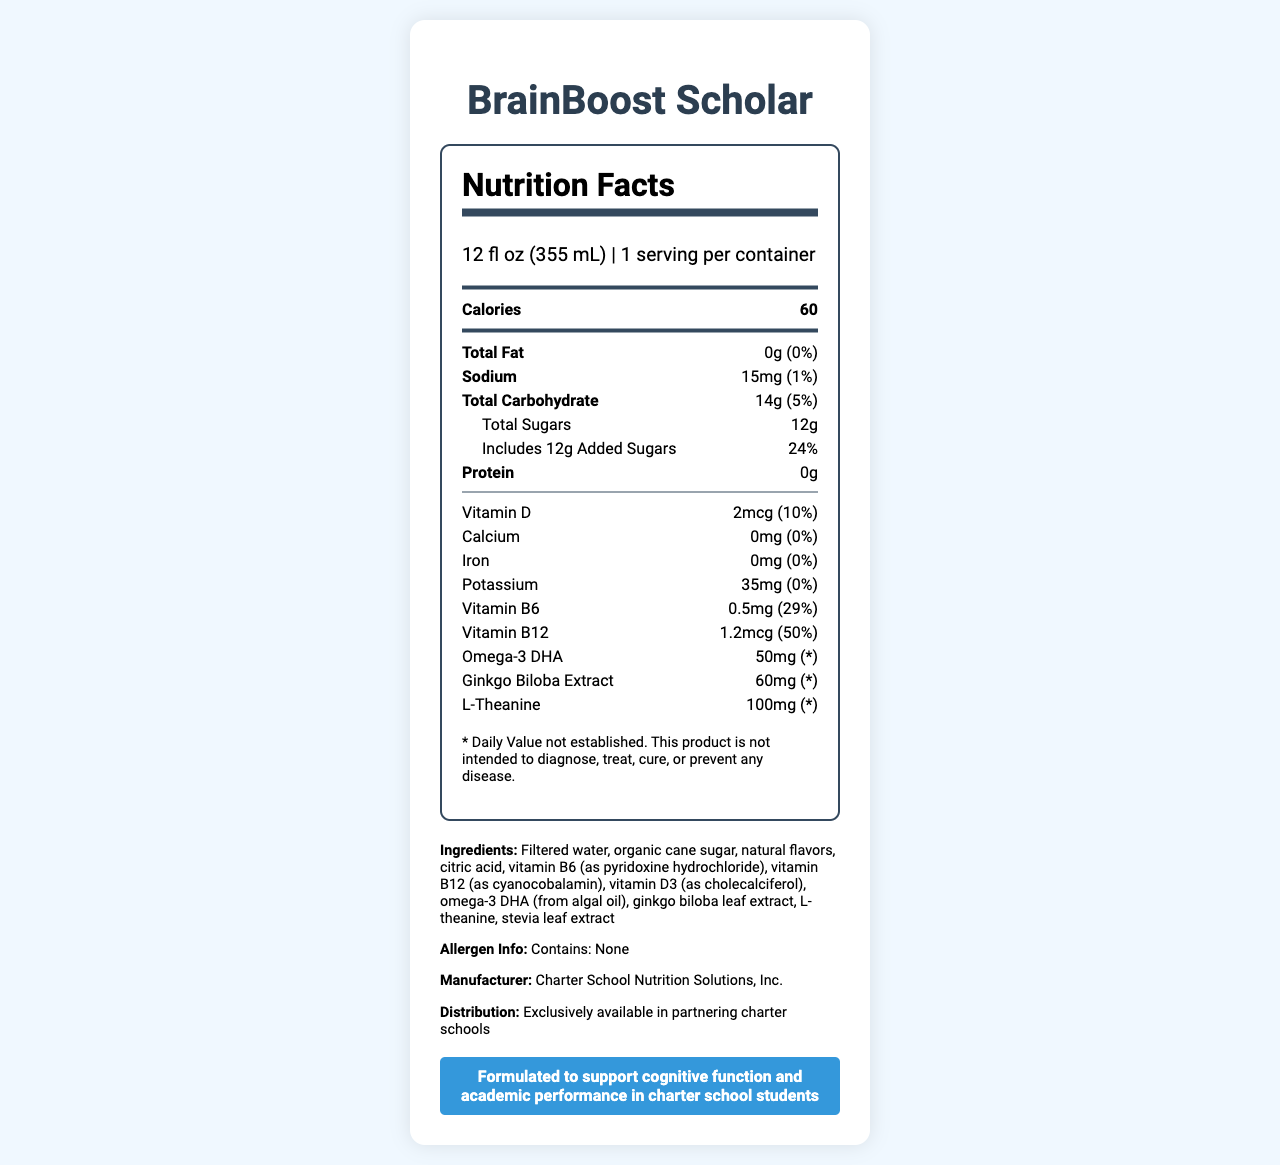which product is mentioned in the document? The product name "BrainBoost Scholar" is prominently displayed at the top of the nutrition facts label.
Answer: BrainBoost Scholar what is the serving size? The serving size is listed near the top of the nutrition label as "12 fl oz (355 mL)."
Answer: 12 fl oz (355 mL) how many calories are in one serving? The calories per serving are shown as "Calories 60" in a bold font.
Answer: 60 what is the amount of sodium per serving? The sodium content per serving is listed as 15mg in the nutrition facts.
Answer: 15mg how much protein does the beverage contain? The protein content is highlighted with the amount "0g" indicated next to it in the nutrition facts.
Answer: 0g how many grams of total sugars are in the beverage? The total sugars are marked as "Total Sugars 12g" in the nutrition facts section.
Answer: 12g what type of vitamins are primarily highlighted in this beverage? The vitamins prominently listed include Vitamin D (2mcg, 10% DV), Vitamin B6 (0.5mg, 29% DV), and Vitamin B12 (1.2mcg, 50% DV).
Answer: Vitamin D, Vitamin B6, and Vitamin B12 which nutrient has the highest Daily Value percentage? A. Sodium B. Vitamin B6 C. Vitamin B12 D. Omega-3 DHA Vitamin B12 has the highest Daily Value percentage at 50%.
Answer: C. Vitamin B12 how many grams of added sugars are in this beverage? A. 0g B. 5g C. 12g D. 14g The added sugars content is shown explicitly as "Includes 12g Added Sugars."
Answer: C. 12g is the product exclusively available in partnering charter schools? The distribution section mentions that the product is "Exclusively available in partnering charter schools."
Answer: Yes does the beverage contain any allergens? The allergen information specified "Contains: None," meaning there are no allergens present in the beverage.
Answer: No what are the main claims made about the beverage’s benefits? The marketing claim mentions that the beverage is aimed at supporting cognitive function and academic performance in charter school students.
Answer: Formulated to support cognitive function and academic performance in charter school students what company manufactures BrainBoost Scholar? The manufacturer is listed as "Charter School Nutrition Solutions, Inc." in the ingredients section.
Answer: Charter School Nutrition Solutions, Inc. does the document provide enough information to determine the exact retail price of the beverage? The document does not include any pricing details or any information related to the retail price of the beverage.
Answer: Not enough information what is the main purpose of the document? The document thoroughly details the nutrition facts, ingredients, claims, and distribution specifics for the BrainBoost Scholar beverage, emphasizing its benefits for students in charter schools.
Answer: The main purpose of the document is to provide the nutrition facts and other relevant information for the BrainBoost Scholar beverage, highlighting its cognitive and academic benefits, ingredients, and availability exclusively at partnering charter schools. 